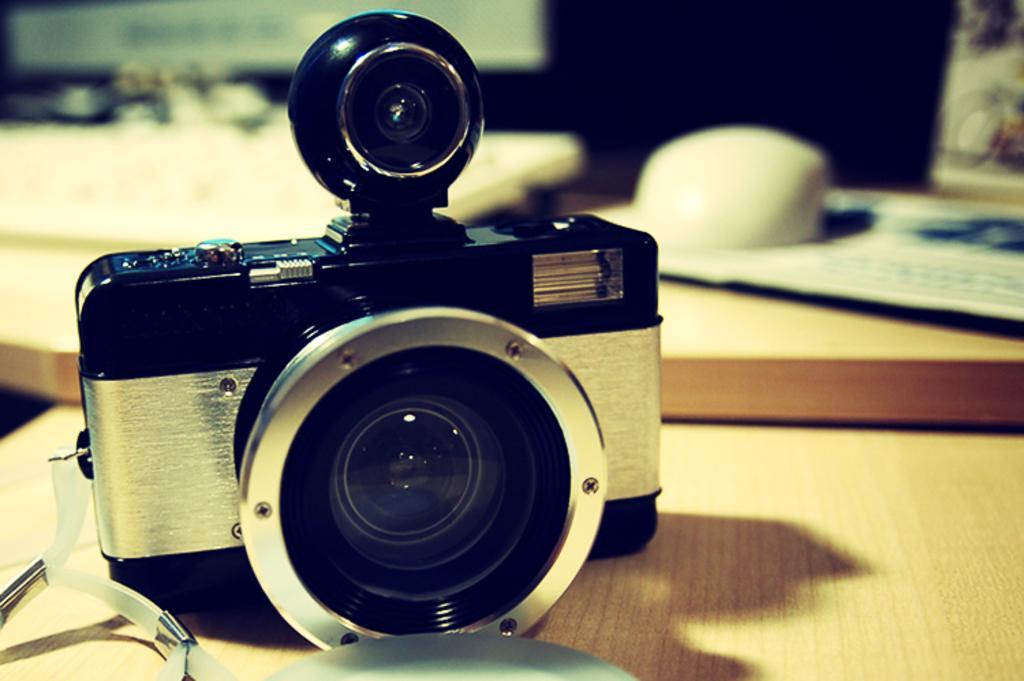Can you describe this image briefly? In the image there is a camera kept on the table and the background of the camera is blur. 